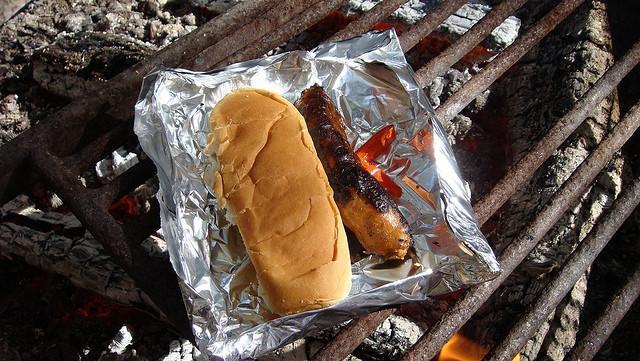How many hot dogs are in the photo?
Give a very brief answer. 2. 